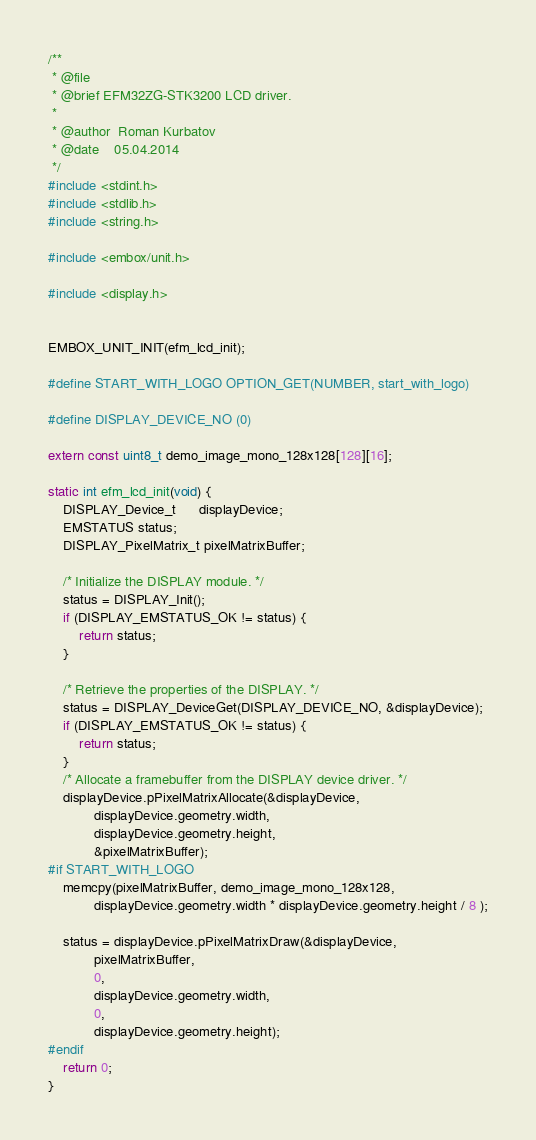Convert code to text. <code><loc_0><loc_0><loc_500><loc_500><_C_>/**
 * @file
 * @brief EFM32ZG-STK3200 LCD driver.
 *
 * @author  Roman Kurbatov
 * @date    05.04.2014
 */
#include <stdint.h>
#include <stdlib.h>
#include <string.h>

#include <embox/unit.h>

#include <display.h>


EMBOX_UNIT_INIT(efm_lcd_init);

#define START_WITH_LOGO OPTION_GET(NUMBER, start_with_logo)

#define DISPLAY_DEVICE_NO (0)

extern const uint8_t demo_image_mono_128x128[128][16];

static int efm_lcd_init(void) {
	DISPLAY_Device_t      displayDevice;
	EMSTATUS status;
	DISPLAY_PixelMatrix_t pixelMatrixBuffer;

	/* Initialize the DISPLAY module. */
	status = DISPLAY_Init();
	if (DISPLAY_EMSTATUS_OK != status) {
		return status;
	}

	/* Retrieve the properties of the DISPLAY. */
	status = DISPLAY_DeviceGet(DISPLAY_DEVICE_NO, &displayDevice);
	if (DISPLAY_EMSTATUS_OK != status) {
		return status;
	}
	/* Allocate a framebuffer from the DISPLAY device driver. */
	displayDevice.pPixelMatrixAllocate(&displayDevice,
			displayDevice.geometry.width,
			displayDevice.geometry.height,
			&pixelMatrixBuffer);
#if START_WITH_LOGO
	memcpy(pixelMatrixBuffer, demo_image_mono_128x128,
			displayDevice.geometry.width * displayDevice.geometry.height / 8 );

	status = displayDevice.pPixelMatrixDraw(&displayDevice,
			pixelMatrixBuffer,
			0,
			displayDevice.geometry.width,
			0,
			displayDevice.geometry.height);
#endif
	return 0;
}
</code> 